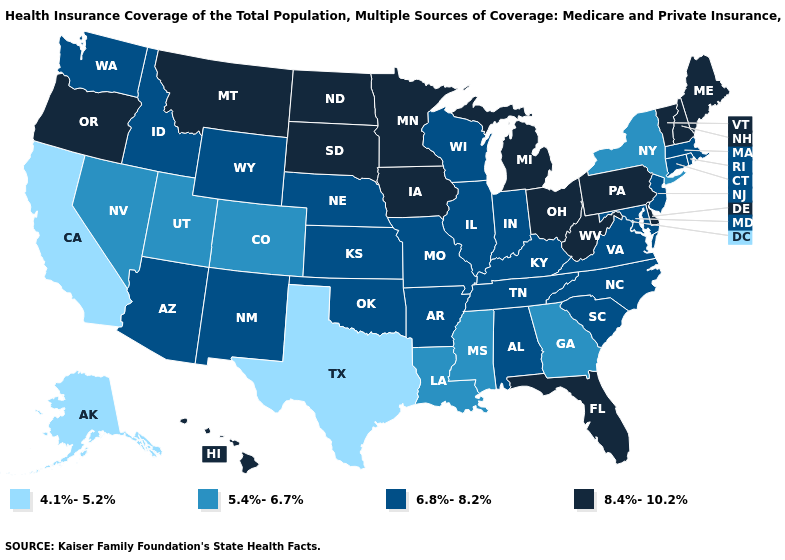What is the value of Idaho?
Short answer required. 6.8%-8.2%. Name the states that have a value in the range 6.8%-8.2%?
Answer briefly. Alabama, Arizona, Arkansas, Connecticut, Idaho, Illinois, Indiana, Kansas, Kentucky, Maryland, Massachusetts, Missouri, Nebraska, New Jersey, New Mexico, North Carolina, Oklahoma, Rhode Island, South Carolina, Tennessee, Virginia, Washington, Wisconsin, Wyoming. Does Oregon have the highest value in the West?
Write a very short answer. Yes. Is the legend a continuous bar?
Write a very short answer. No. Does North Carolina have the lowest value in the South?
Concise answer only. No. What is the value of North Carolina?
Short answer required. 6.8%-8.2%. Among the states that border Georgia , which have the highest value?
Quick response, please. Florida. What is the lowest value in the West?
Keep it brief. 4.1%-5.2%. What is the value of Florida?
Keep it brief. 8.4%-10.2%. What is the value of New Jersey?
Quick response, please. 6.8%-8.2%. Name the states that have a value in the range 4.1%-5.2%?
Be succinct. Alaska, California, Texas. Among the states that border Ohio , does Pennsylvania have the highest value?
Answer briefly. Yes. What is the highest value in states that border Ohio?
Be succinct. 8.4%-10.2%. Does Nebraska have the highest value in the USA?
Write a very short answer. No. Does the first symbol in the legend represent the smallest category?
Keep it brief. Yes. 